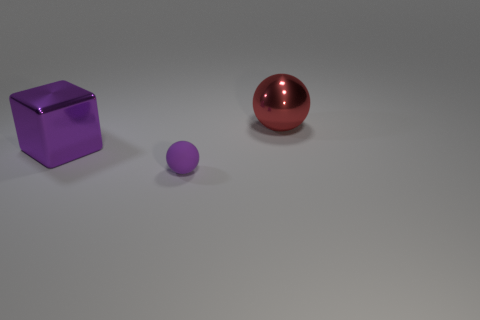What is the big thing in front of the sphere that is behind the purple object on the right side of the purple block made of?
Your answer should be very brief. Metal. There is a purple thing left of the purple rubber ball; how many big things are behind it?
Keep it short and to the point. 1. There is another matte object that is the same shape as the red object; what color is it?
Offer a terse response. Purple. Does the large red object have the same material as the tiny purple ball?
Provide a short and direct response. No. How many spheres are big brown metal objects or big metallic objects?
Offer a very short reply. 1. How big is the ball to the left of the sphere behind the ball that is in front of the large red thing?
Make the answer very short. Small. The purple rubber object that is the same shape as the big red metallic object is what size?
Make the answer very short. Small. There is a big cube; what number of big metal spheres are behind it?
Provide a short and direct response. 1. Do the metal object that is left of the purple rubber object and the large metal ball have the same color?
Your answer should be compact. No. What number of gray things are either metallic blocks or rubber balls?
Keep it short and to the point. 0. 